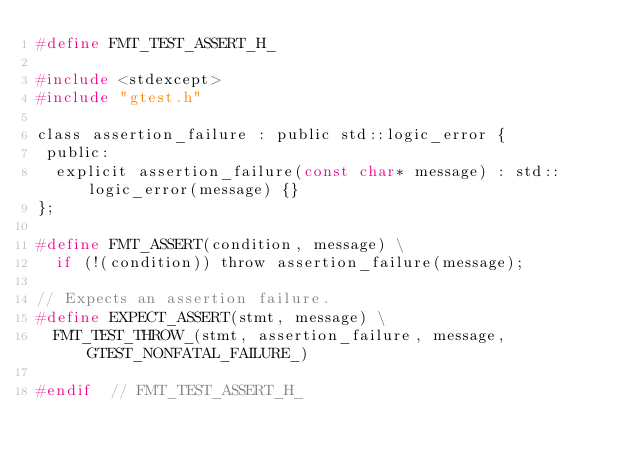<code> <loc_0><loc_0><loc_500><loc_500><_C_>#define FMT_TEST_ASSERT_H_

#include <stdexcept>
#include "gtest.h"

class assertion_failure : public std::logic_error {
 public:
  explicit assertion_failure(const char* message) : std::logic_error(message) {}
};

#define FMT_ASSERT(condition, message) \
  if (!(condition)) throw assertion_failure(message);

// Expects an assertion failure.
#define EXPECT_ASSERT(stmt, message) \
  FMT_TEST_THROW_(stmt, assertion_failure, message, GTEST_NONFATAL_FAILURE_)

#endif  // FMT_TEST_ASSERT_H_
</code> 